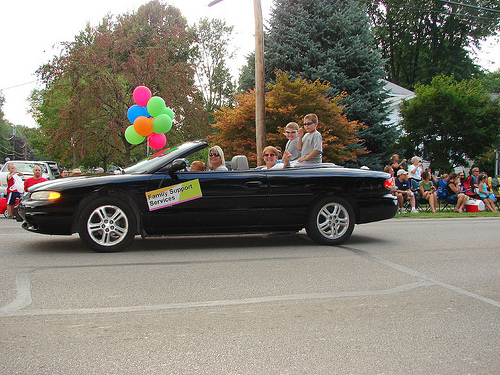<image>
Is the tree to the left of the balloon? Yes. From this viewpoint, the tree is positioned to the left side relative to the balloon. Is there a wheel in the car? No. The wheel is not contained within the car. These objects have a different spatial relationship. 